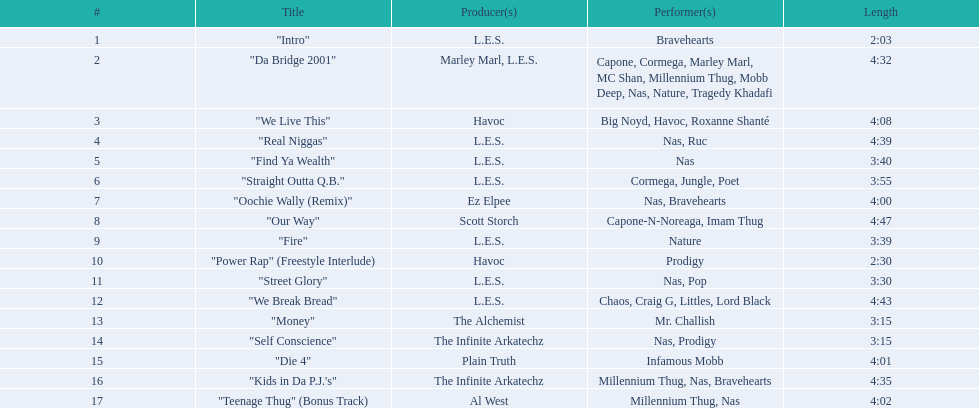What are the complete list of tracks on the album? "Intro", "Da Bridge 2001", "We Live This", "Real Niggas", "Find Ya Wealth", "Straight Outta Q.B.", "Oochie Wally (Remix)", "Our Way", "Fire", "Power Rap" (Freestyle Interlude), "Street Glory", "We Break Bread", "Money", "Self Conscience", "Die 4", "Kids in Da P.J.'s", "Teenage Thug" (Bonus Track). Which one is the briefest? "Intro". What is the duration of that track? 2:03. 